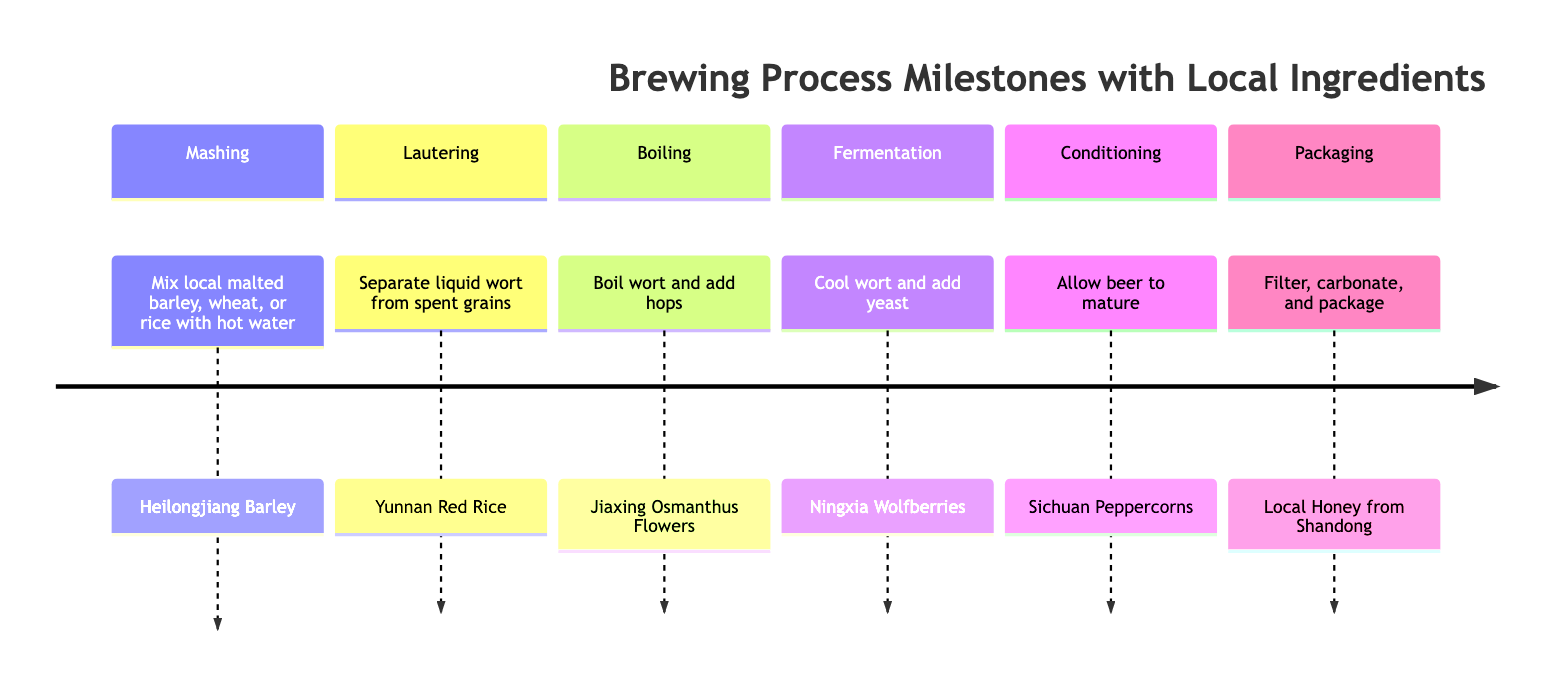What's the first step in the brewing process? The diagram lists the first step in the brewing process as "Mashing," which involves mixing local malted barley, wheat, or rice with hot water to convert starches into fermentable sugars.
Answer: Mashing How many milestones are there in total? The timeline contains six distinct sections or milestones, each representing a specific step in the brewing process.
Answer: 6 What local ingredient is used during fermentation? According to the diagram, the local ingredient used in the fermentation step is "Ningxia Wolfberries (Goji Berries)."
Answer: Ningxia Wolfberries Which step comes after boiling? By analyzing the timeline, the step following "Boiling" is "Fermentation." This is the order of steps listed in the diagram.
Answer: Fermentation What is the local ingredient used during packaging? The diagram indicates that the local ingredient used in the packaging step is "Local Honey from Shandong."
Answer: Local Honey from Shandong How does the lautering process relate to the mashing step? Lautering directly follows the mashing step in the brewing process. First, mashing converts starches into sugars, and then lautering separates the liquid wort for boiling.
Answer: They are consecutive steps What step involves adding hops? The step that involves adding hops occurs during the "Boiling" stage of the brewing process.
Answer: Boiling Which local ingredient is added during conditioning? In the conditioning step, the local ingredient mentioned is "Sichuan Peppercorns." This flavor component is crucial for the maturation process of the beer.
Answer: Sichuan Peppercorns 